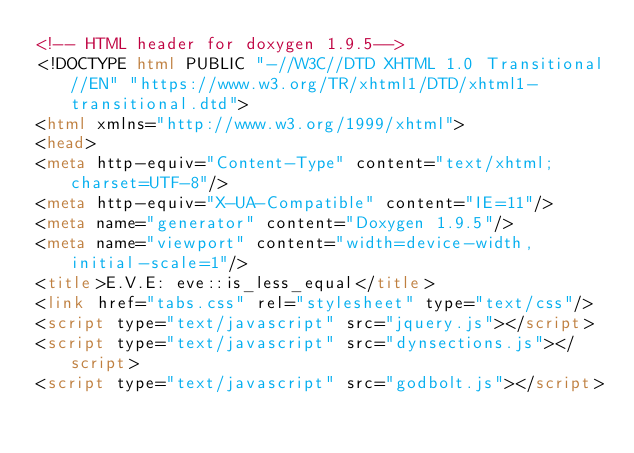Convert code to text. <code><loc_0><loc_0><loc_500><loc_500><_HTML_><!-- HTML header for doxygen 1.9.5-->
<!DOCTYPE html PUBLIC "-//W3C//DTD XHTML 1.0 Transitional//EN" "https://www.w3.org/TR/xhtml1/DTD/xhtml1-transitional.dtd">
<html xmlns="http://www.w3.org/1999/xhtml">
<head>
<meta http-equiv="Content-Type" content="text/xhtml;charset=UTF-8"/>
<meta http-equiv="X-UA-Compatible" content="IE=11"/>
<meta name="generator" content="Doxygen 1.9.5"/>
<meta name="viewport" content="width=device-width, initial-scale=1"/>
<title>E.V.E: eve::is_less_equal</title>
<link href="tabs.css" rel="stylesheet" type="text/css"/>
<script type="text/javascript" src="jquery.js"></script>
<script type="text/javascript" src="dynsections.js"></script>
<script type="text/javascript" src="godbolt.js"></script></code> 